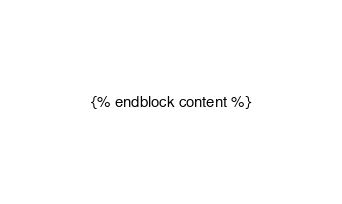Convert code to text. <code><loc_0><loc_0><loc_500><loc_500><_HTML_>{% endblock content %}
</code> 